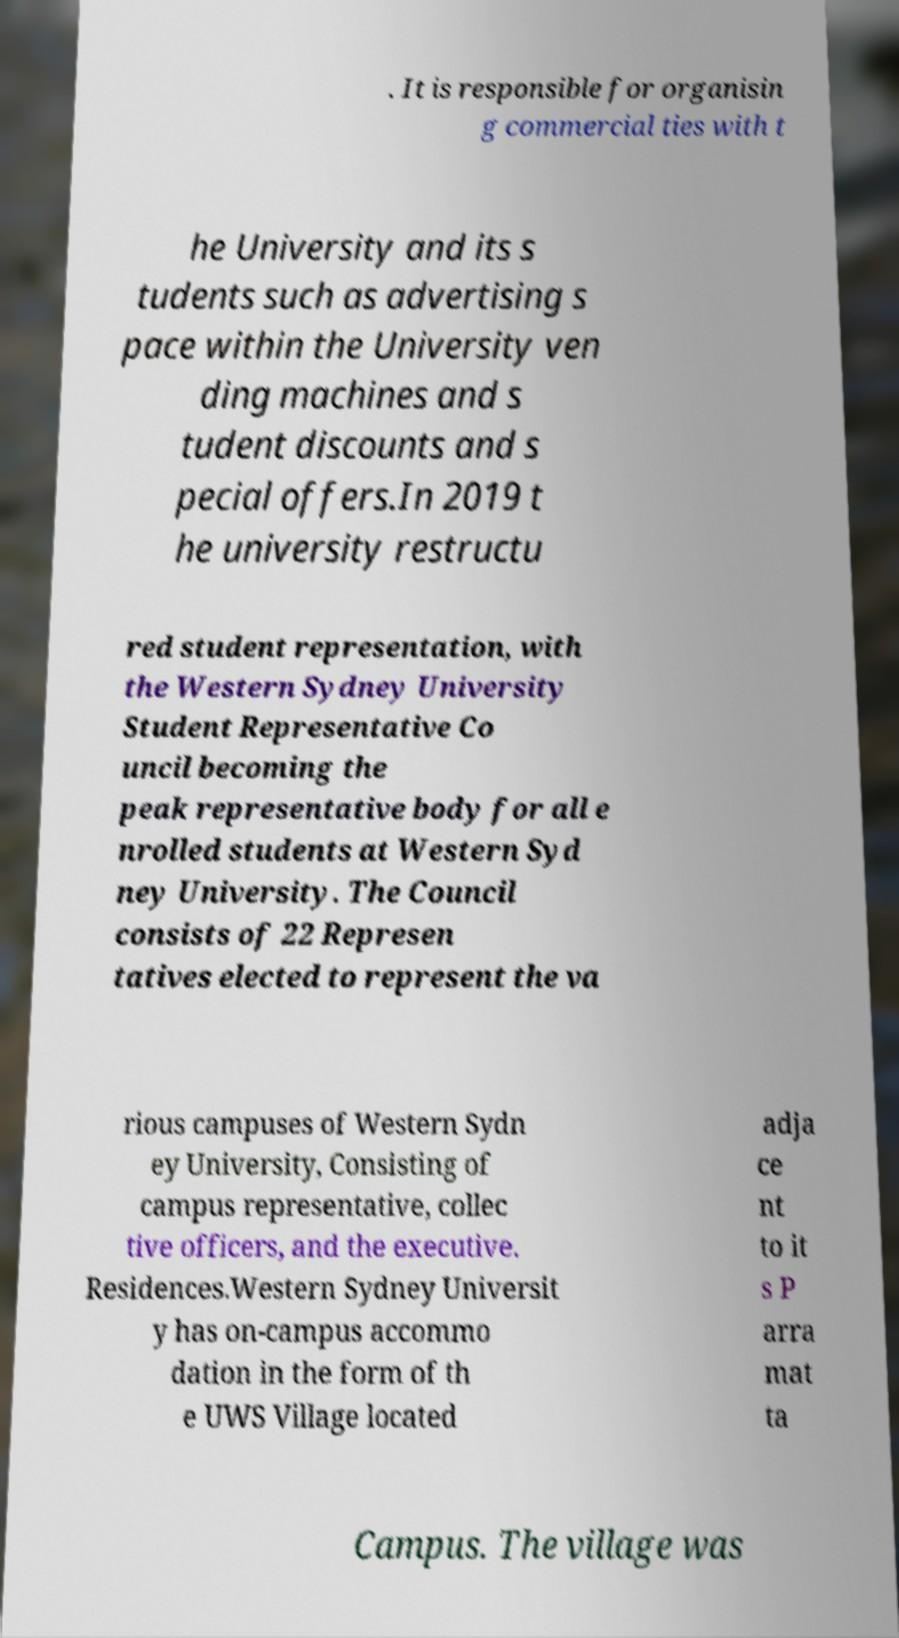I need the written content from this picture converted into text. Can you do that? . It is responsible for organisin g commercial ties with t he University and its s tudents such as advertising s pace within the University ven ding machines and s tudent discounts and s pecial offers.In 2019 t he university restructu red student representation, with the Western Sydney University Student Representative Co uncil becoming the peak representative body for all e nrolled students at Western Syd ney University. The Council consists of 22 Represen tatives elected to represent the va rious campuses of Western Sydn ey University, Consisting of campus representative, collec tive officers, and the executive. Residences.Western Sydney Universit y has on-campus accommo dation in the form of th e UWS Village located adja ce nt to it s P arra mat ta Campus. The village was 